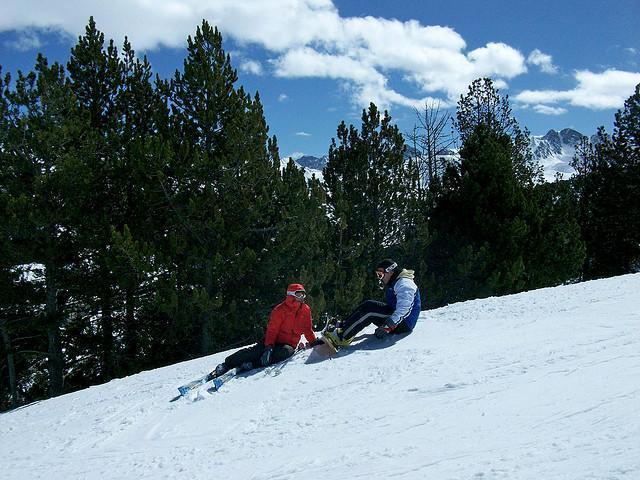How many people can be seen?
Give a very brief answer. 2. 